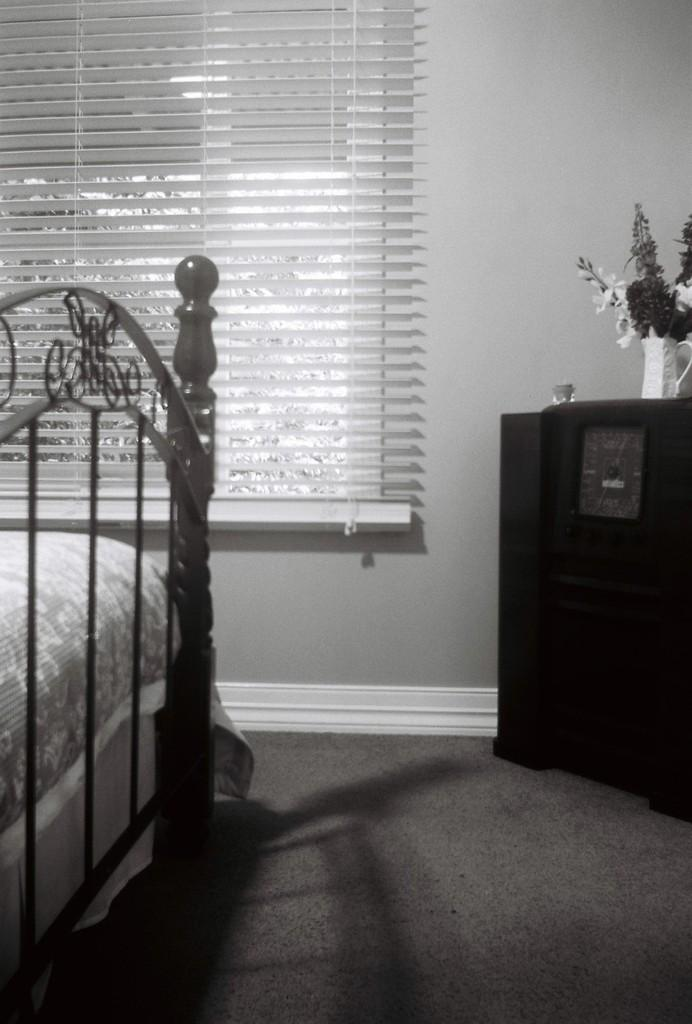What type of setting is shown in the image? The image depicts an inside view of a room. What piece of furniture can be seen in the room? There is a bed in the room. What type of window treatment is present in the room? Window blinds are present in the room. What decorative item can be seen in the room? There is a flower vase in the room. What is the texture of the chin of the person in the image? There is no person present in the image, so it is not possible to determine the texture of their chin. 